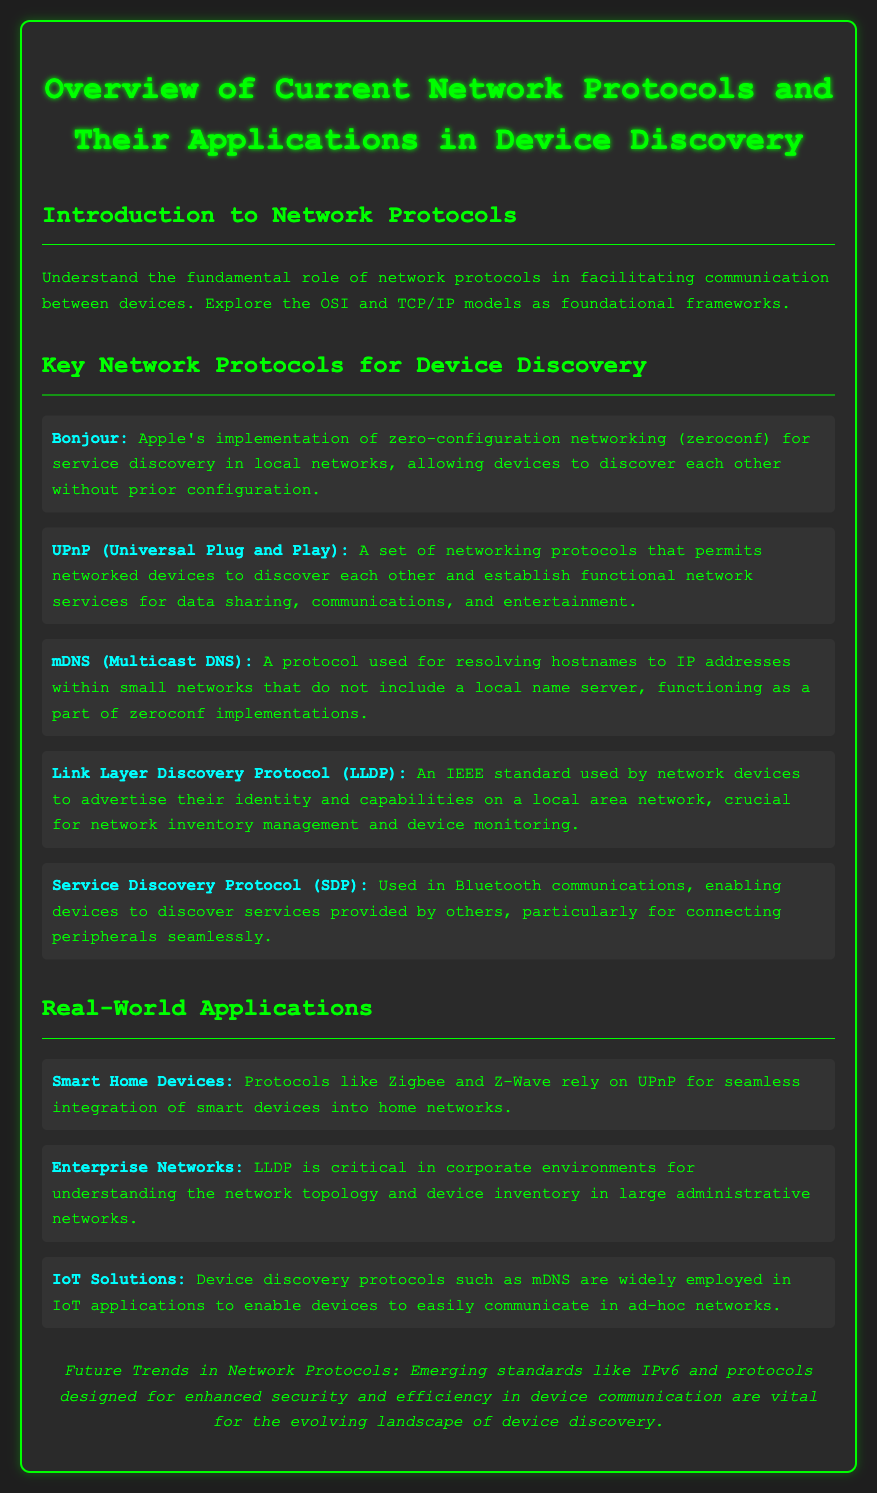What is Bonjour? Bonjour is Apple's implementation of zero-configuration networking (zeroconf) for service discovery in local networks.
Answer: Apple's implementation of zero-configuration networking What protocol is used for Bluetooth communications? The document mentions the Service Discovery Protocol (SDP) as being used in Bluetooth communications.
Answer: Service Discovery Protocol (SDP) Which protocol allows devices to advertise their identity on a local area network? Link Layer Discovery Protocol (LLDP) is identified as the protocol used by network devices to advertise their identity and capabilities.
Answer: Link Layer Discovery Protocol (LLDP) What are Zigbee and Z-Wave protocols used for? The document states that Zigbee and Z-Wave rely on UPnP for seamless integration of smart devices into home networks.
Answer: Integration of smart devices into home networks What is a key trend in future network protocols? The document emphasizes that emerging standards like IPv6 and protocols designed for enhanced security and efficiency are vital.
Answer: IPv6 and enhanced security protocols Which protocol is critical in corporate environments for network topology understanding? LLDP is highlighted as being critical in corporate environments for understanding network topology and device inventory.
Answer: LLDP How do mDNS protocols support IoT applications? The document describes mDNS as widely employed in IoT applications to enable easy communication in ad-hoc networks.
Answer: To enable devices to easily communicate in ad-hoc networks What fundamental role do network protocols play? Network protocols facilitate communication between devices, according to the introductory section of the document.
Answer: Facilitate communication between devices What does UPnP stand for? The acronym UPnP stands for Universal Plug and Play.
Answer: Universal Plug and Play 